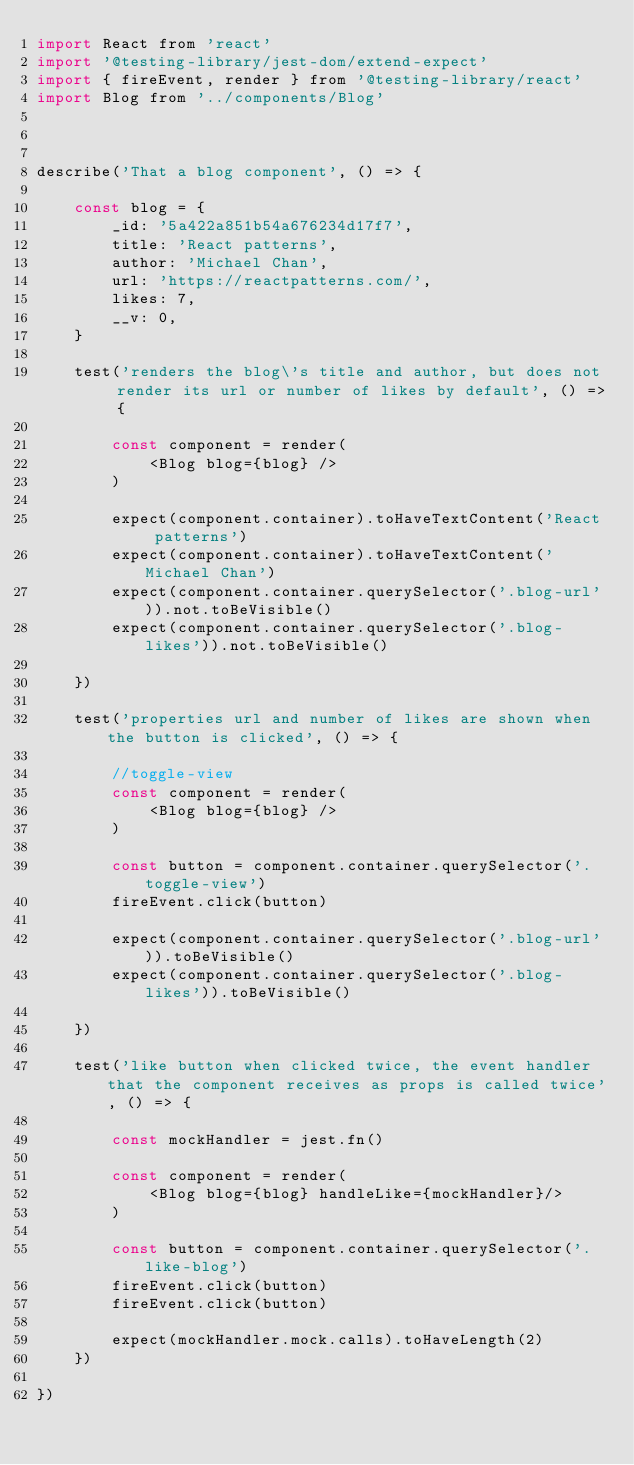<code> <loc_0><loc_0><loc_500><loc_500><_JavaScript_>import React from 'react'
import '@testing-library/jest-dom/extend-expect'
import { fireEvent, render } from '@testing-library/react'
import Blog from '../components/Blog'



describe('That a blog component', () => {

    const blog = {
        _id: '5a422a851b54a676234d17f7',
        title: 'React patterns',
        author: 'Michael Chan',
        url: 'https://reactpatterns.com/',
        likes: 7,
        __v: 0,
    }

    test('renders the blog\'s title and author, but does not render its url or number of likes by default', () => {

        const component = render(
            <Blog blog={blog} />
        )

        expect(component.container).toHaveTextContent('React patterns')
        expect(component.container).toHaveTextContent('Michael Chan')
        expect(component.container.querySelector('.blog-url')).not.toBeVisible()
        expect(component.container.querySelector('.blog-likes')).not.toBeVisible()

    })

    test('properties url and number of likes are shown when the button is clicked', () => {

        //toggle-view
        const component = render(
            <Blog blog={blog} />
        )

        const button = component.container.querySelector('.toggle-view')
        fireEvent.click(button)

        expect(component.container.querySelector('.blog-url')).toBeVisible()
        expect(component.container.querySelector('.blog-likes')).toBeVisible()

    })

    test('like button when clicked twice, the event handler that the component receives as props is called twice', () => {

        const mockHandler = jest.fn()

        const component = render(
            <Blog blog={blog} handleLike={mockHandler}/>
        )

        const button = component.container.querySelector('.like-blog')
        fireEvent.click(button)
        fireEvent.click(button)

        expect(mockHandler.mock.calls).toHaveLength(2)
    })

})</code> 